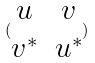Convert formula to latex. <formula><loc_0><loc_0><loc_500><loc_500>( \begin{matrix} u & v \\ v ^ { * } & u ^ { * } \end{matrix} )</formula> 